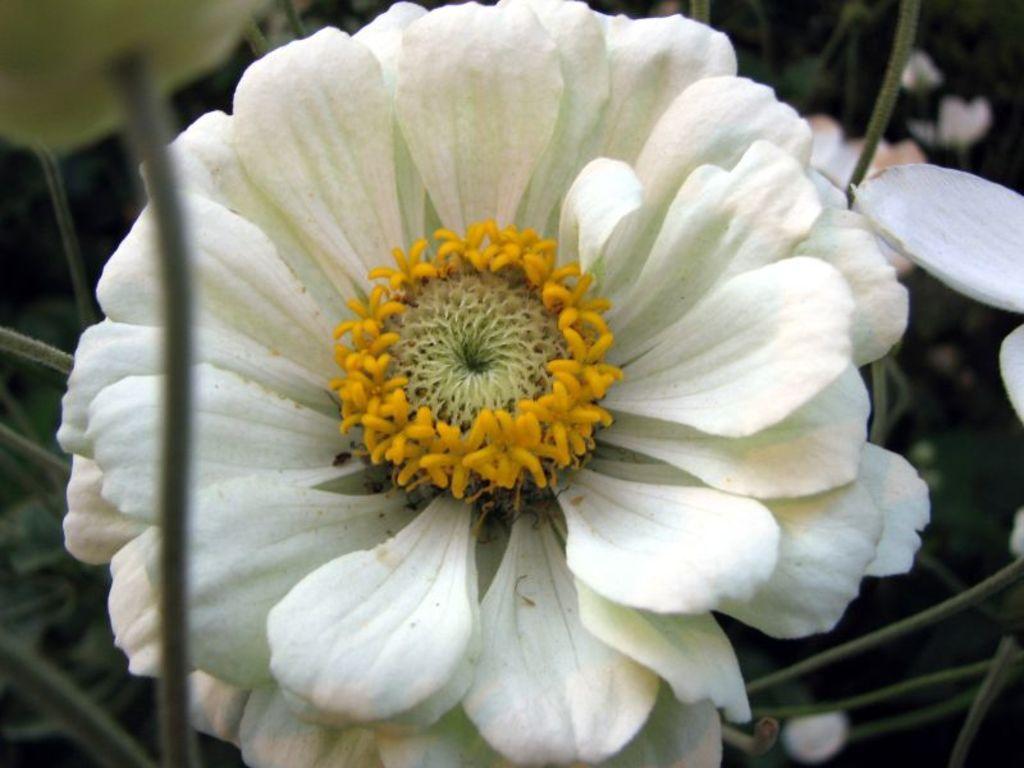Please provide a concise description of this image. In this image there is a white flower, there is a flower towards the right of the image, there is a flower truncated towards the top of the image. 